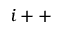Convert formula to latex. <formula><loc_0><loc_0><loc_500><loc_500>\ \ i + +</formula> 